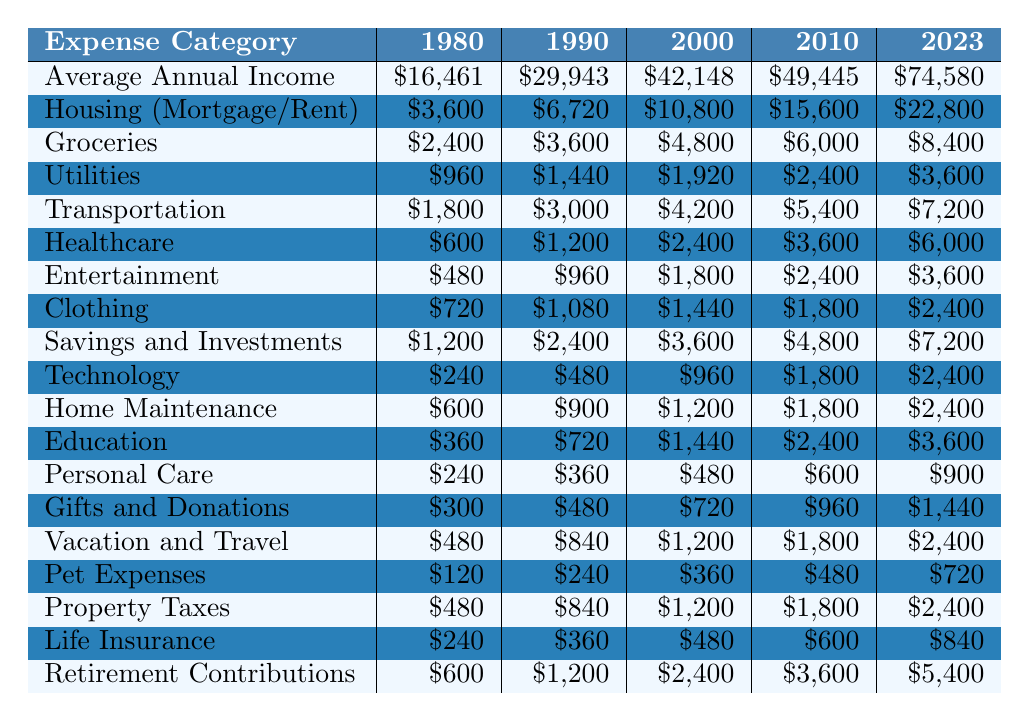What was the average annual income in 1980? According to the table, the average annual income for the year 1980 is listed as $16,461.
Answer: $16,461 How much did households spend on healthcare in 2023? The table shows that healthcare expenses in 2023 amount to $6,000.
Answer: $6,000 What category saw the largest increase in expenses from 1980 to 2023? By comparing the expenses in each category, the increase in housing costs from $3,600 to $22,800 shows the largest change, a difference of $19,200.
Answer: Housing How much more did families spend on groceries in 2023 compared to 1980? The grocery expense in 2023 is $8,400, while in 1980 it was $2,400. The difference is calculated as $8,400 - $2,400 = $6,000.
Answer: $6,000 True or False: In 2010, the expenses for transportation were lower than those for healthcare. In 2010, transportation costs were $5,400, and healthcare costs were $3,600. Since $5,400 > $3,600, the statement is false.
Answer: False What is the total spending on technology for the years 2000 to 2023? The technology expenses in those years are $960 (2000), $1,800 (2010), and $2,400 (2023). Summing these values gives $960 + $1,800 + $2,400 = $5,160.
Answer: $5,160 What is the percentage increase in entertainment expenses from 2000 to 2023? The entertainment cost in 2000 is $1,800 and in 2023 it is $3,600. The percentage increase is calculated as (($3,600 - $1,800) / $1,800) * 100% = 100%.
Answer: 100% What was the total amount spent on personal care across all reported years? The personal care expenses are $240 (1980), $360 (1990), $480 (2000), $600 (2010), and $900 (2023). The total is $240 + $360 + $480 + $600 + $900 = $2,580.
Answer: $2,580 Between which two years did healthcare expenses see the largest absolute increase? The healthcare expenses increased from $2,400 in 2000 to $3,600 in 2010, an increase of $1,200. But the increase from $3,600 (2010) to $6,000 (2023) is greater, at $2,400. The largest increase was between 2010 and 2023.
Answer: 2010 and 2023 How much did the total expenses on clothing and personal care add up to in 1990? Clothing expenses in 1990 were $1,080 and personal care expenses were $360. The total expenses then would be $1,080 + $360 = $1,440.
Answer: $1,440 